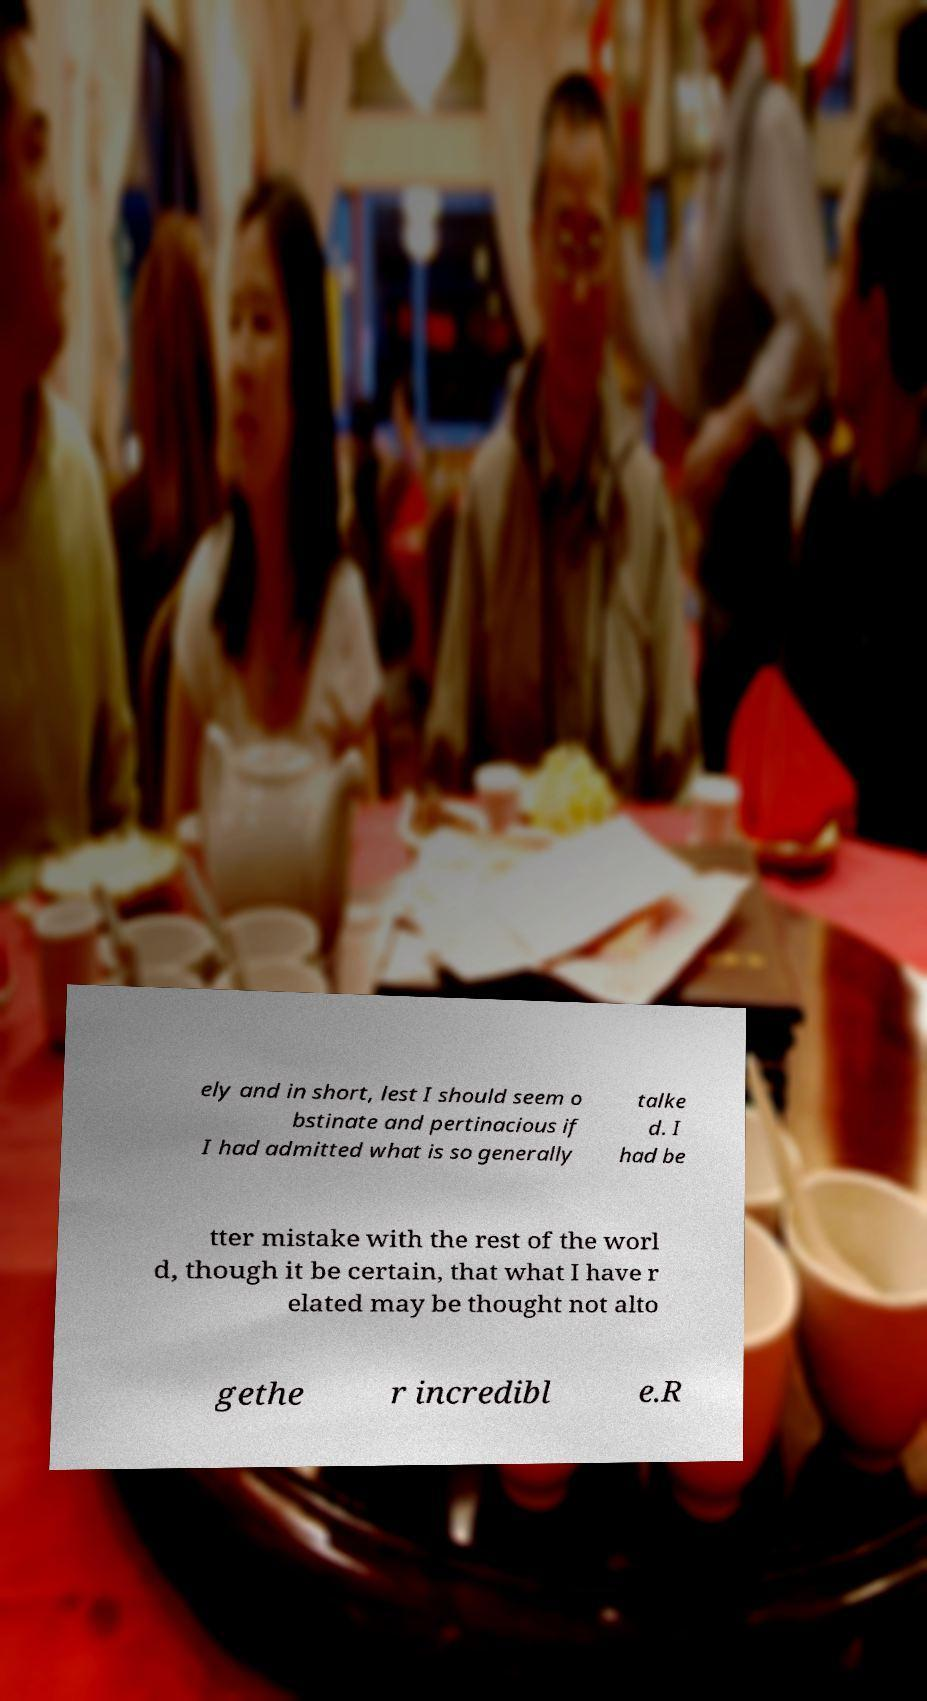Could you extract and type out the text from this image? ely and in short, lest I should seem o bstinate and pertinacious if I had admitted what is so generally talke d. I had be tter mistake with the rest of the worl d, though it be certain, that what I have r elated may be thought not alto gethe r incredibl e.R 